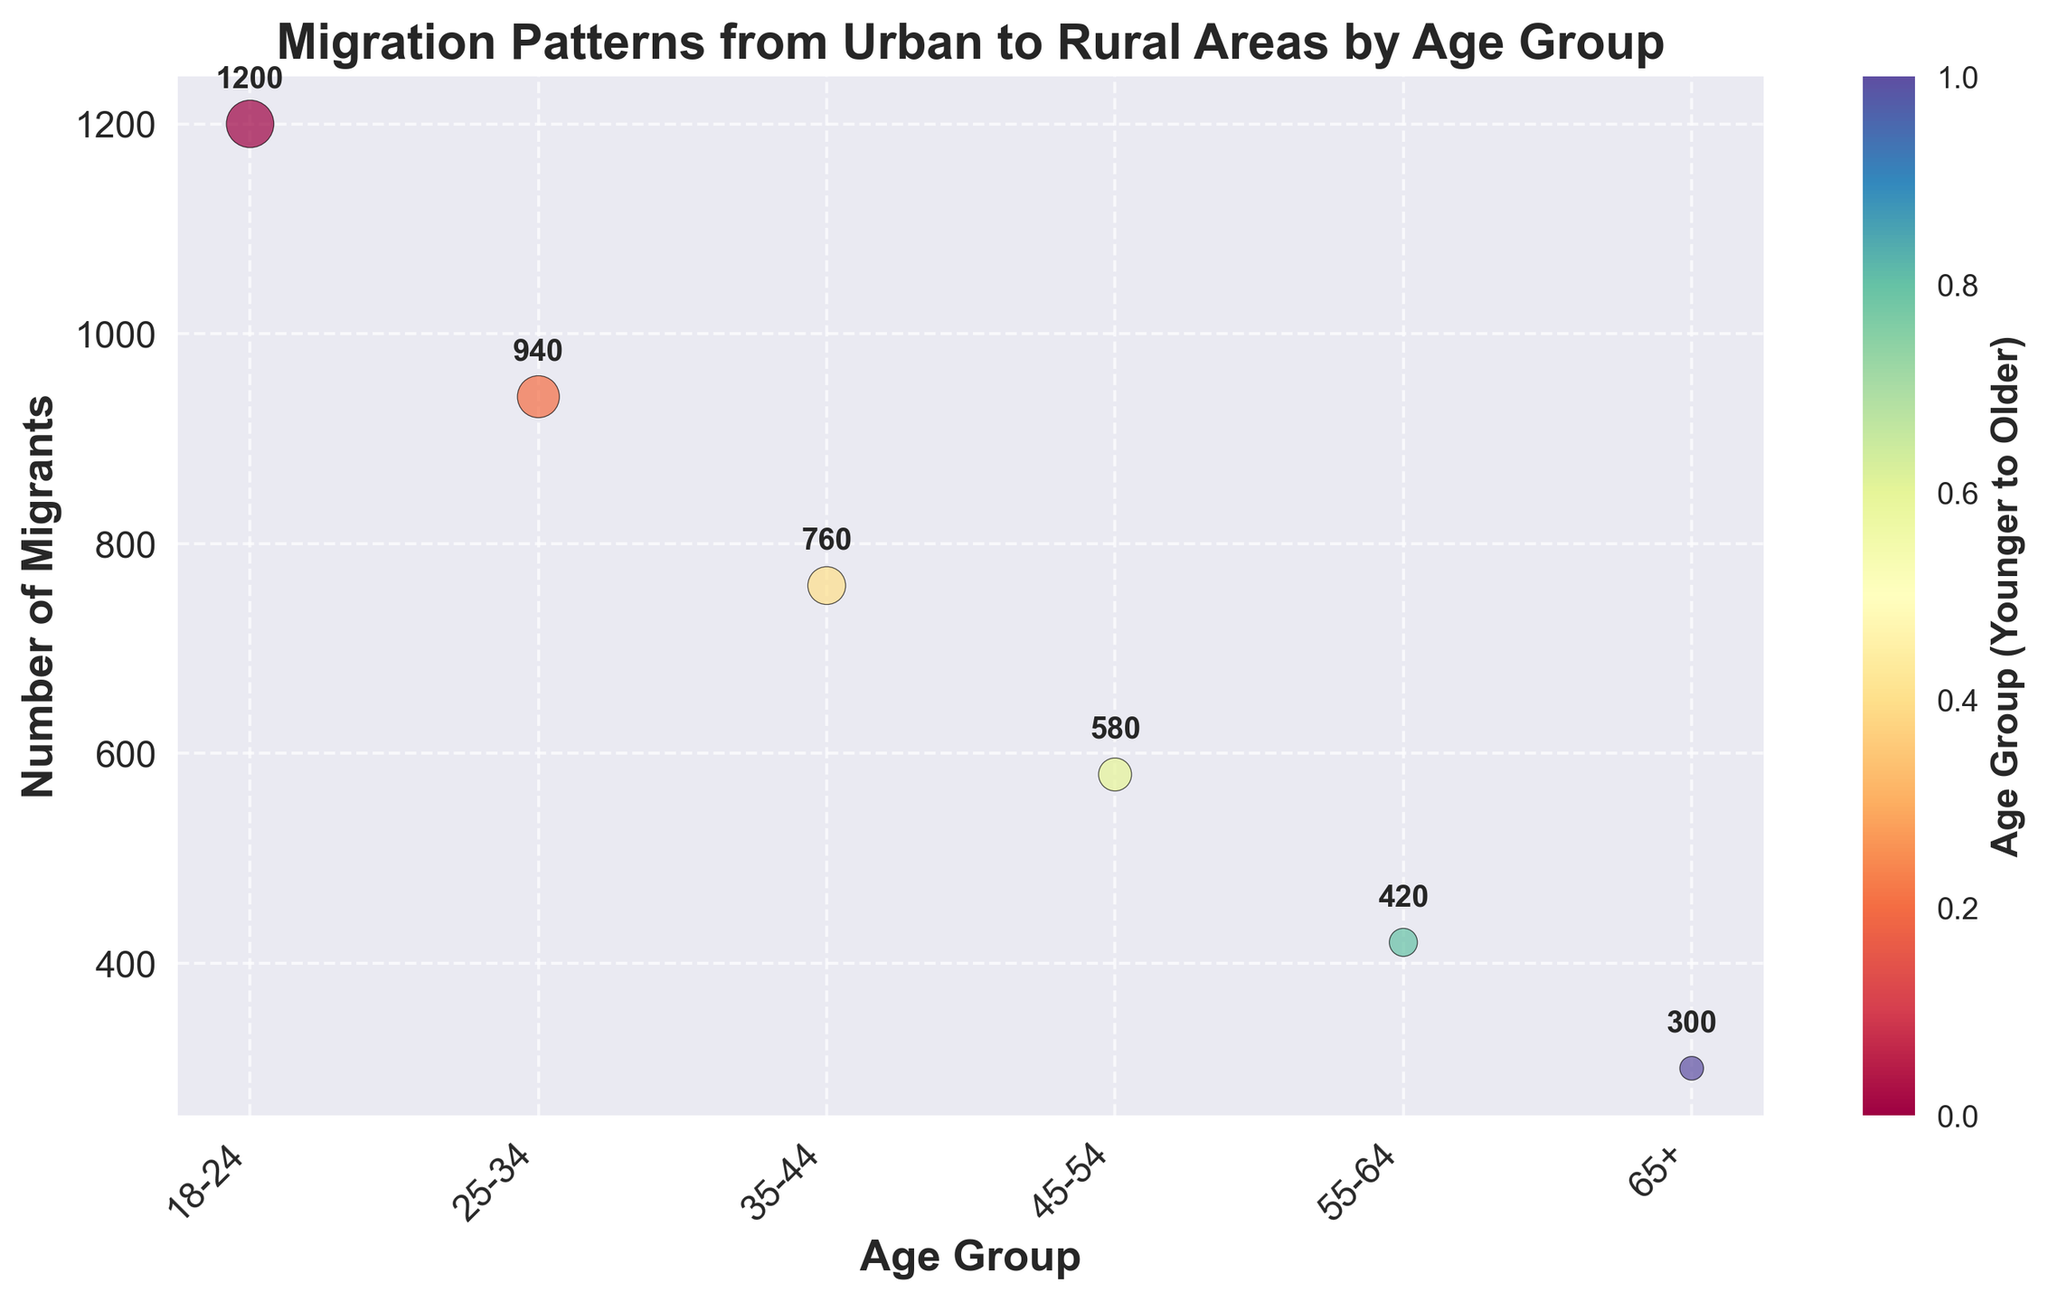How many age groups are displayed in the plot? The x-axis of the scatter plot lists the different age groups displayed in the plot. By counting them, we identify six distinct age groups (18-24, 25-34, 35-44, 45-54, 55-64, 65+).
Answer: Six What is the title of the plot? The title of the plot is displayed at the top and provides a summary of what the plot is about. It reads 'Migration Patterns from Urban to Rural Areas by Age Group'.
Answer: Migration Patterns from Urban to Rural Areas by Age Group Which age group has the highest number of migrants? By looking at the y-axis (Number of Migrants) and identifying the point that goes the highest, the 18-24 age group is at the topmost point, indicating it has the highest number of migrants.
Answer: 18-24 What is the total number of migrants across all age groups? To find the total, sum the number of migrants from all age groups: 1200 + 940 + 760 + 580 + 420 + 300 = 4200.
Answer: 4200 What is the difference in the number of migrants between the age group 18-24 and 65+? By subtracting the number of migrants in the 65+ age group (300) from the number of migrants in the 18-24 age group (1200) we get: 1200 - 300 = 900.
Answer: 900 How does the color difference relate to the age groups? The colors are mapped to age groups using a gradient (Spectral colormap), where younger age groups have brighter colors and older age groups have darker colors, as shown by the color bar legend.
Answer: Colors indicate age groups from younger to older Among the age groups 35-44 and 45-54, which has fewer migrants? By comparing the y-axis values of the two age groups, 35-44 has 760 migrants while 45-54 has 580 migrants. Therefore, 45-54 has fewer migrants.
Answer: 45-54 What is the trend in the number of migrants across age groups? Observing the scatter plot, the number of migrants decreases as the age group increases, showing a downward trend from 18-24 to 65+.
Answer: Decreases with age Which two age groups have a difference in the number of migrants of 420? Comparing the given data values, we see that the difference between age groups 18-24 and 25-34 is: 1200 - 940 = 260, between 25-34 and 35-44 is: 940 - 760 = 180, and so on. The difference of 420 occurs between age groups 25-34 (940) and 55-64 (420).
Answer: 25-34 and 55-64 What is the average number of migrants across all age groups? First, find the total number of migrants (4200). Then, divide this by the number of age groups (6): 4200 / 6 = 700.
Answer: 700 